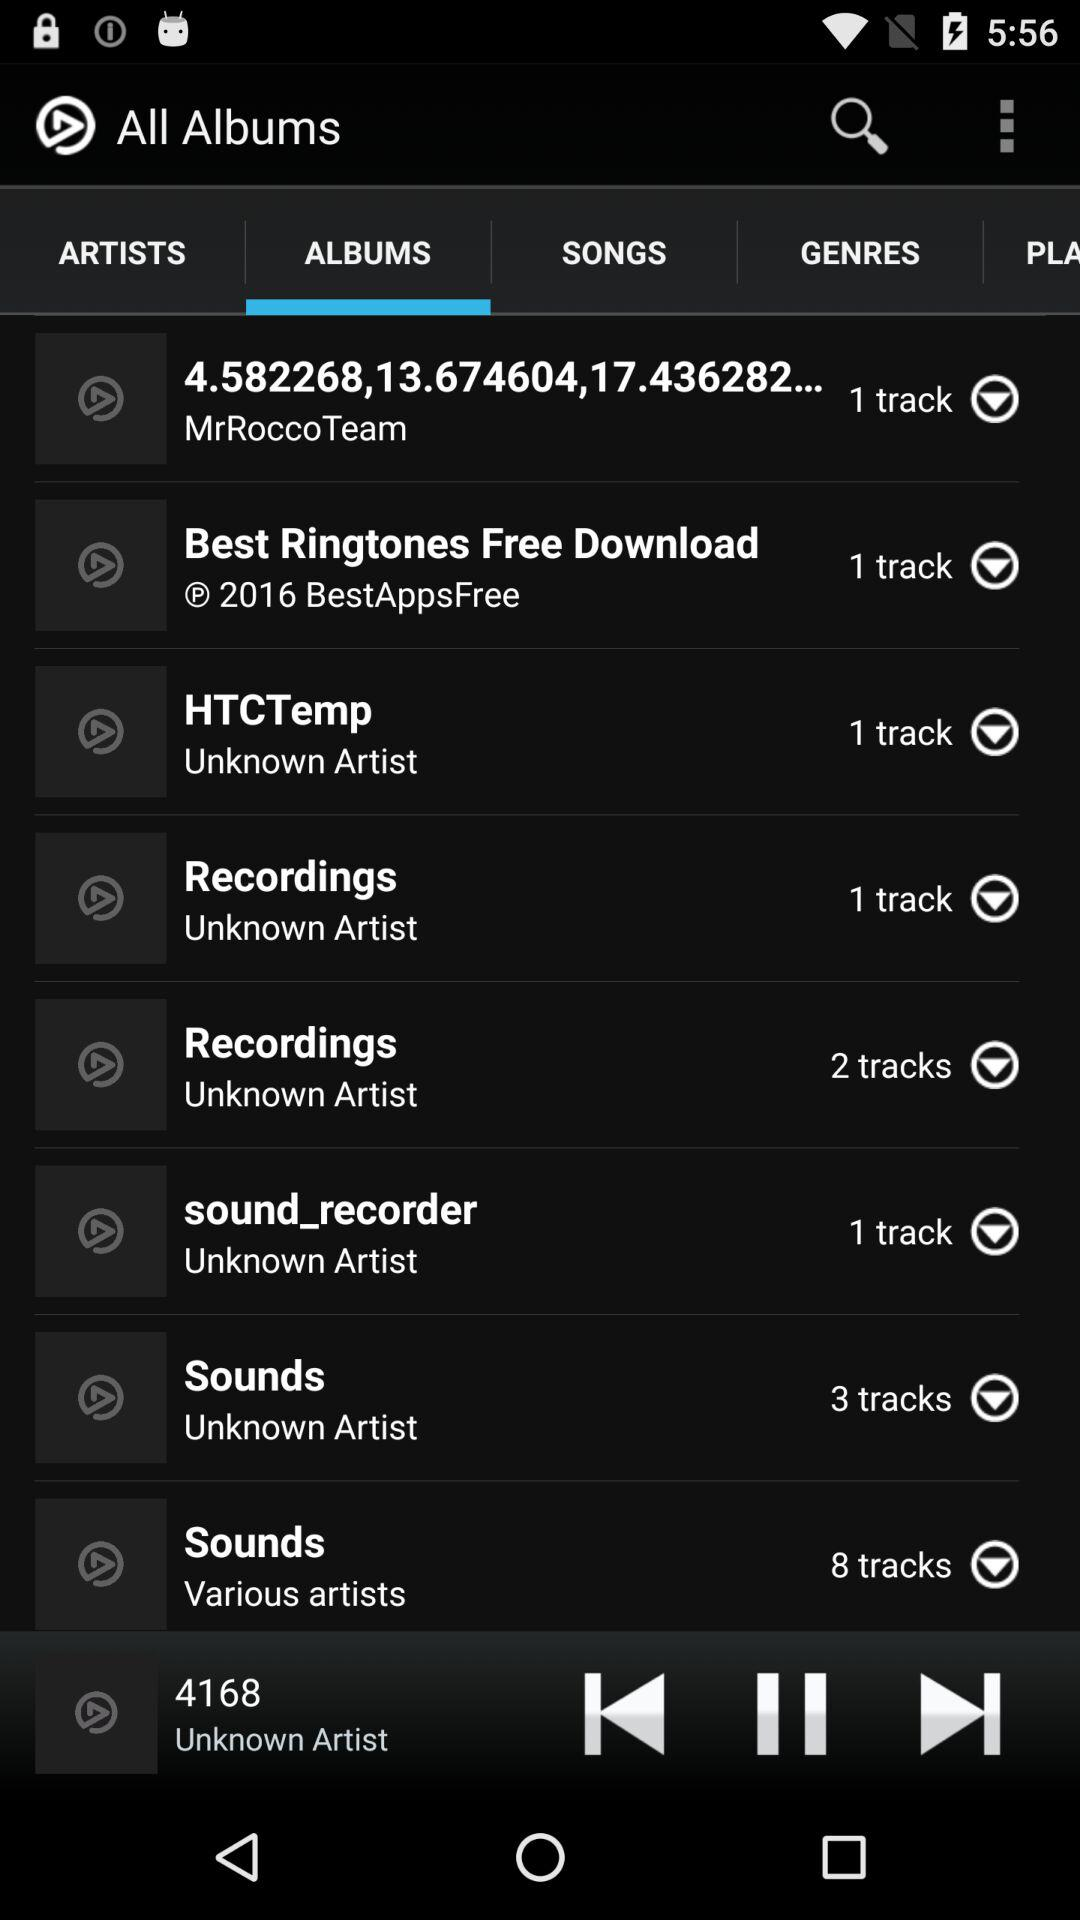Which tab is selected? The selected tab is "ALBUMS". 